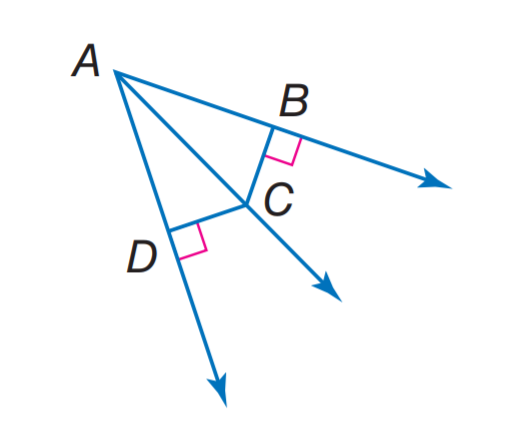Question: m \angle B A C = 40, m \angle D A C = 40, and D C = 10, find B C.
Choices:
A. 10
B. 20
C. 30
D. 40
Answer with the letter. Answer: A 